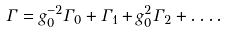Convert formula to latex. <formula><loc_0><loc_0><loc_500><loc_500>\Gamma = g _ { 0 } ^ { - 2 } \Gamma _ { 0 } + \Gamma _ { 1 } + g _ { 0 } ^ { 2 } \Gamma _ { 2 } + \dots .</formula> 